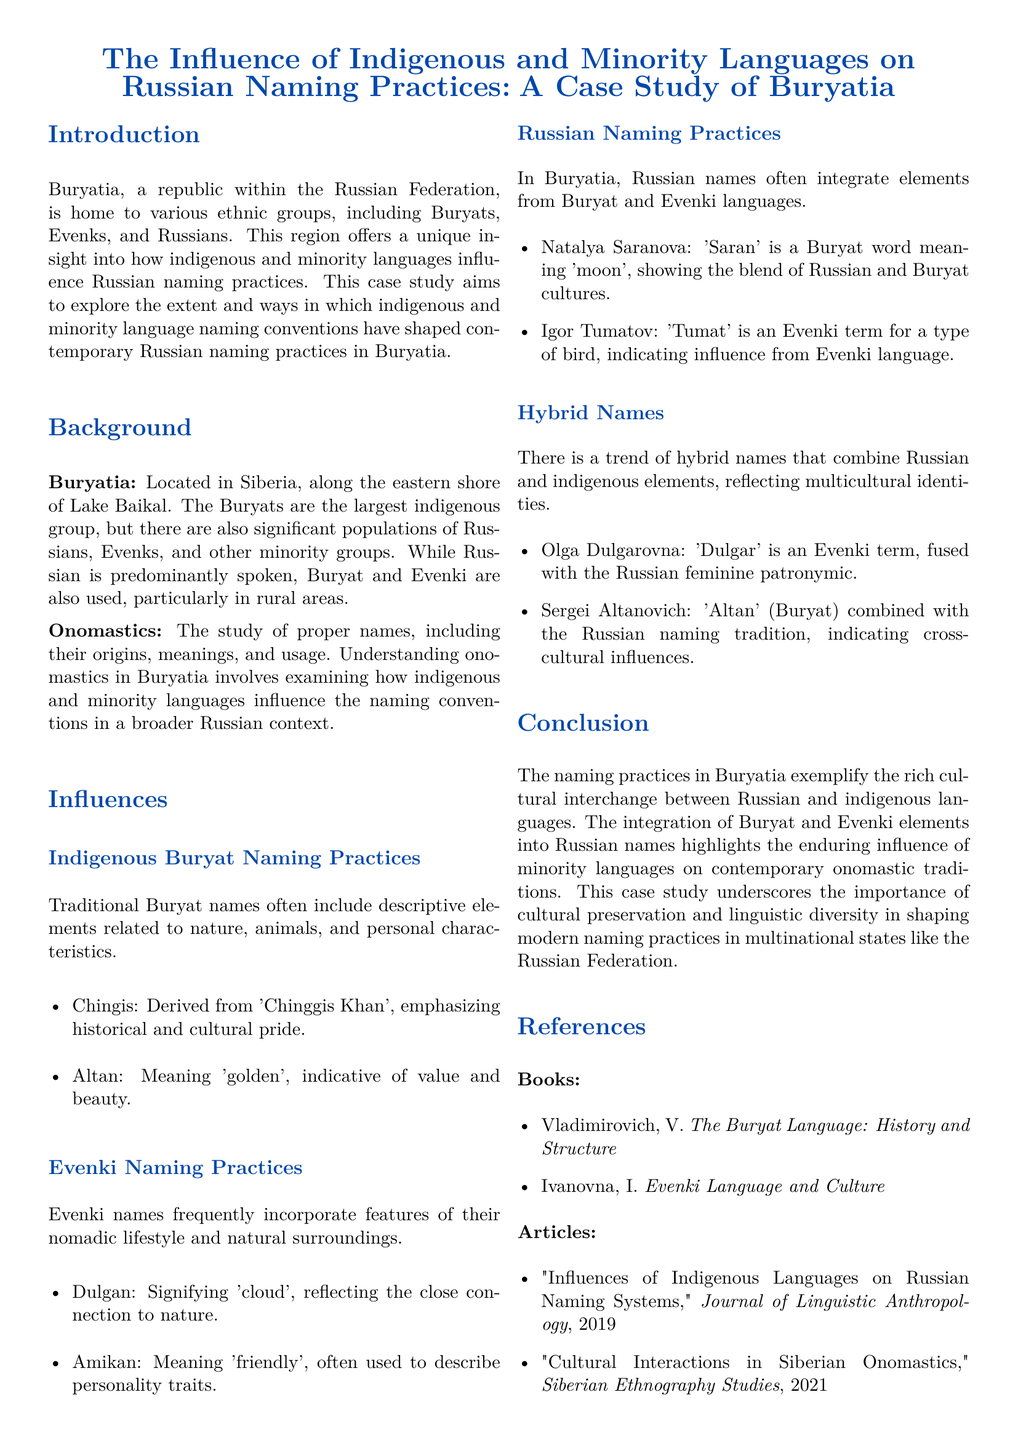What is the largest indigenous group in Buryatia? The document states that the Buryats are the largest indigenous group in Buryatia.
Answer: Buryats What does the name "Altan" mean? The document mentions that "Altan" means 'golden', indicative of value and beauty.
Answer: golden What is the Evenki term for 'cloud'? According to the document, "Dulgan" signifies 'cloud' in Evenki.
Answer: Dulgan What type of names are created by combining Russian and indigenous elements? The document refers to these as hybrid names that reflect multicultural identities.
Answer: hybrid names What is the publication year of the article titled "Cultural Interactions in Siberian Onomastics"? The document lists the publication year of this article as 2021.
Answer: 2021 What natural feature does the Evenki name "Amikan" reflect? The document explains that "Amikan" means 'friendly', often describing personality traits, indicating a connection to personal characteristics.
Answer: personality traits What is the emphasis of the name "Chingis"? The document states that "Chingis" emphasizes historical and cultural pride.
Answer: historical and cultural pride Which languages influence Russian naming practices in Buryatia? The document indicates that Buryat and Evenki languages influence Russian naming practices.
Answer: Buryat and Evenki What do the surveyed naming practices exemplify? The conclusion states that these practices exemplify the rich cultural interchange between Russian and indigenous languages.
Answer: rich cultural interchange 